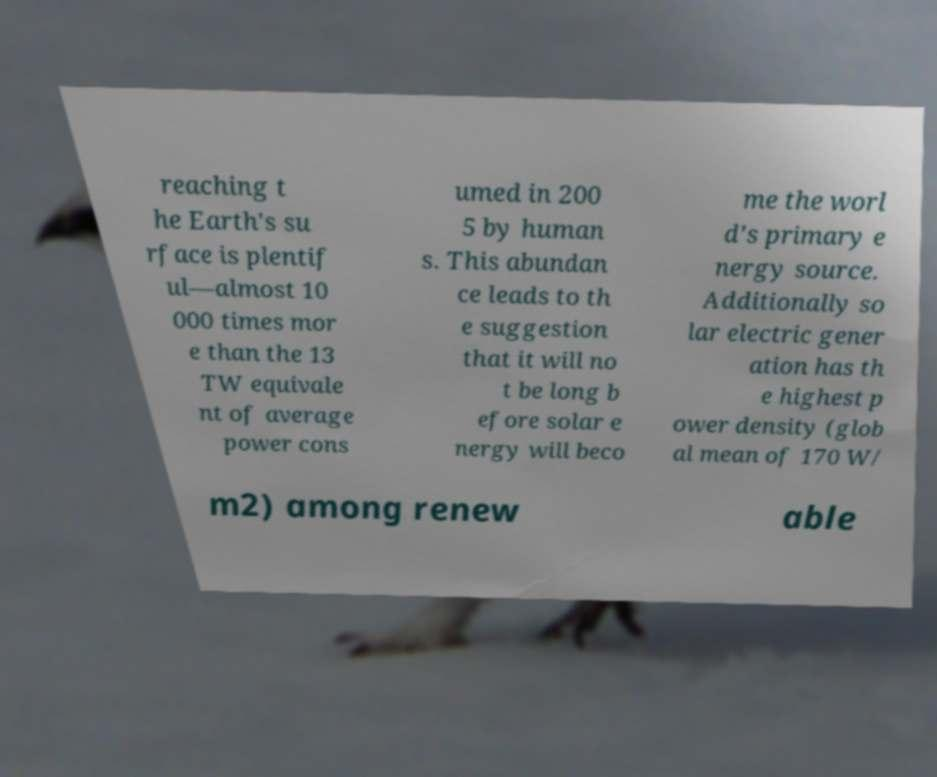Please identify and transcribe the text found in this image. reaching t he Earth's su rface is plentif ul—almost 10 000 times mor e than the 13 TW equivale nt of average power cons umed in 200 5 by human s. This abundan ce leads to th e suggestion that it will no t be long b efore solar e nergy will beco me the worl d's primary e nergy source. Additionally so lar electric gener ation has th e highest p ower density (glob al mean of 170 W/ m2) among renew able 